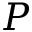Convert formula to latex. <formula><loc_0><loc_0><loc_500><loc_500>P</formula> 